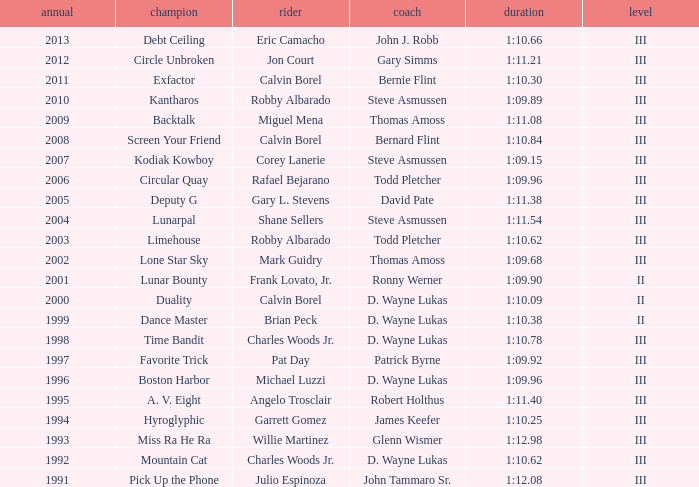Which trainer had a time of 1:10.09 with a year less than 2009? D. Wayne Lukas. 